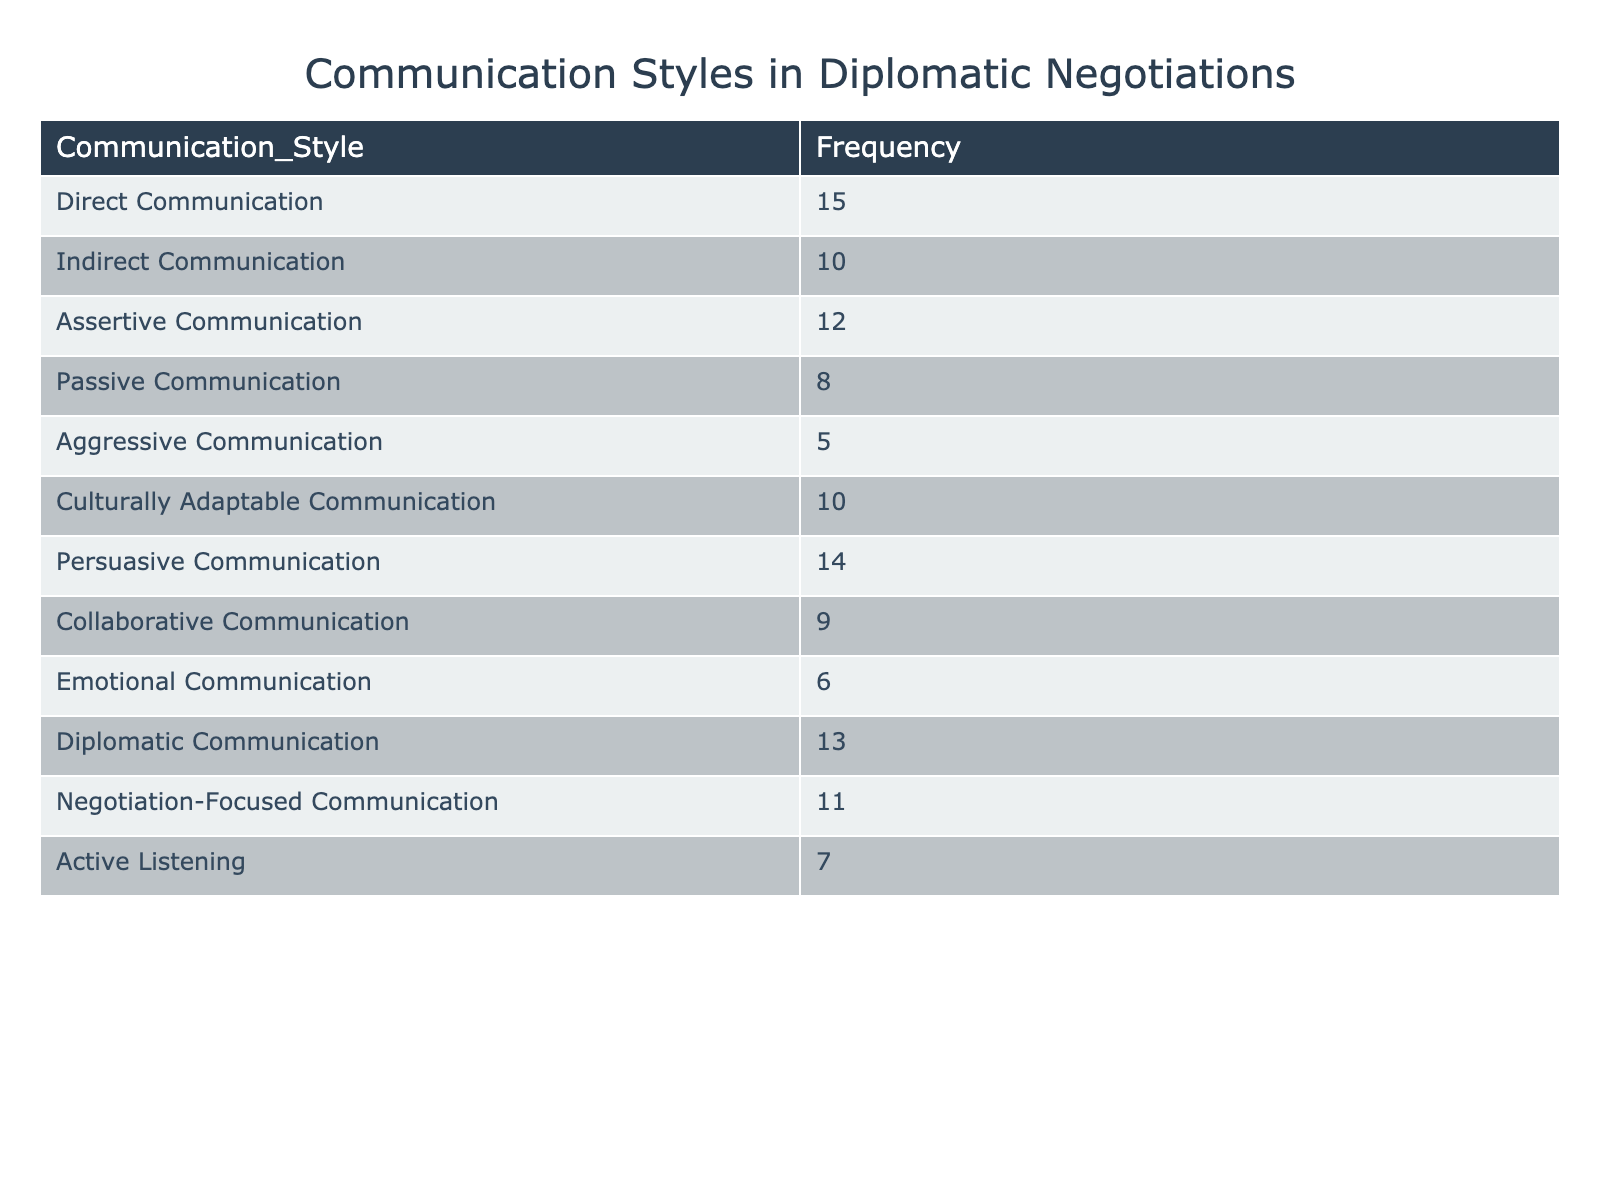What is the frequency of Direct Communication? The table lists Direct Communication with a frequency of 15, which is mentioned directly in the corresponding row.
Answer: 15 Which communication style has the lowest frequency? Examining the frequency values, Aggressive Communication has a frequency of 5, which is lower than all other styles listed in the table.
Answer: Aggressive Communication What is the total frequency of Culturally Adaptable Communication and Emotional Communication combined? Culturally Adaptable Communication has a frequency of 10, while Emotional Communication has a frequency of 6. Adding them together gives 10 + 6 = 16.
Answer: 16 Is the frequency of Assertive Communication greater than that of Collaborative Communication? Assertive Communication has a frequency of 12 and Collaborative Communication has a frequency of 9. Since 12 is greater than 9, the statement is true.
Answer: Yes What is the average frequency of all communication styles listed in the table? First, we add all the frequencies: 15 + 10 + 12 + 8 + 5 + 10 + 14 + 9 + 6 + 13 + 11 + 7 =  2 + 15 + 10 + 12 + 8 + 5 + 10 + 14 + 9 + 6 + 13 + 11 + 7 =  7 + 14 + 12 + 8 + 5 + 10 + 14 + 9 + 6 + 13 + 11 + 7 =  7 + 8 + 5 + 10 + 14 + 9 + 6 + 13 + 11 + 7 =  8 + 5 + 10 + 14 + 9 + 6 + 13 + 11 + 7 =  1 + 2 + 22 =  1 + 2 + 12 + 8 + 5 + 10 + 14 + 9 + 6 + 13 + 11 + 7 = 154. There are 12 communication styles, so the average is 154 / 12 ≈ 12.83.
Answer: Approximately 12.83 Which two communication styles have the same frequency? Looking through the table, we see that Indirect Communication and Culturally Adaptable Communication both have a frequency of 10, indicating they are equal.
Answer: Indirect Communication and Culturally Adaptable Communication 